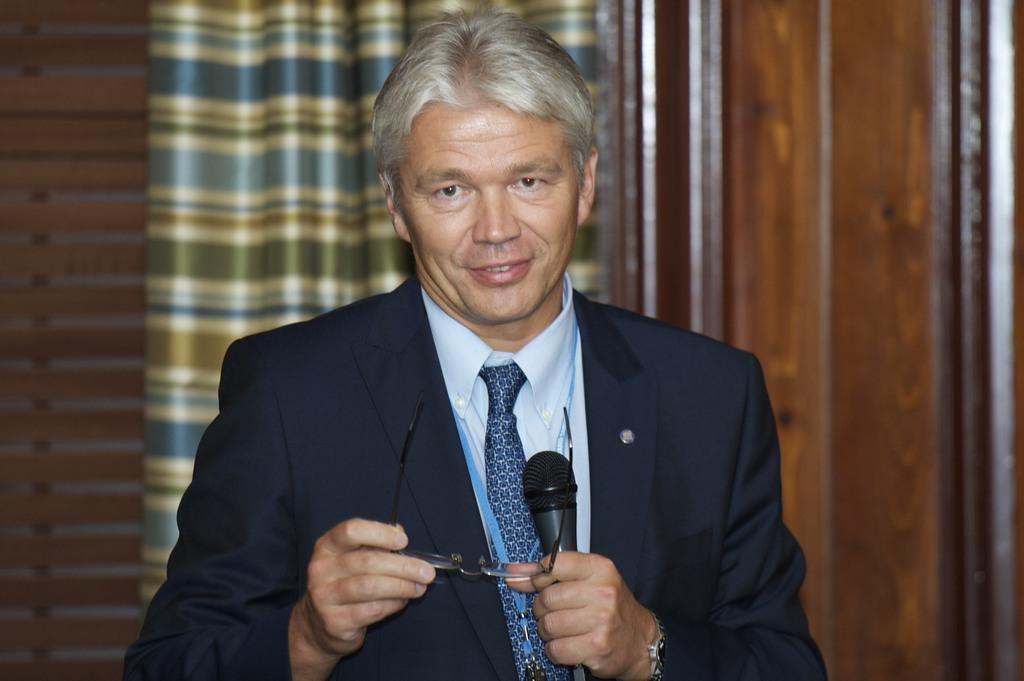How many people are in the image? There is one person in the image. What is the person holding in their hands? The person is holding spectacles and a microphone. What can be seen in the background of the image? There is a curtain in the background of the image. What type of wall is visible on the right side of the image? There is a wooden wall on the right side of the image. What type of store can be seen in the image? There is no store present in the image. What noise is being made by the person in the image? The image does not provide any information about noise or sounds being made by the person. 